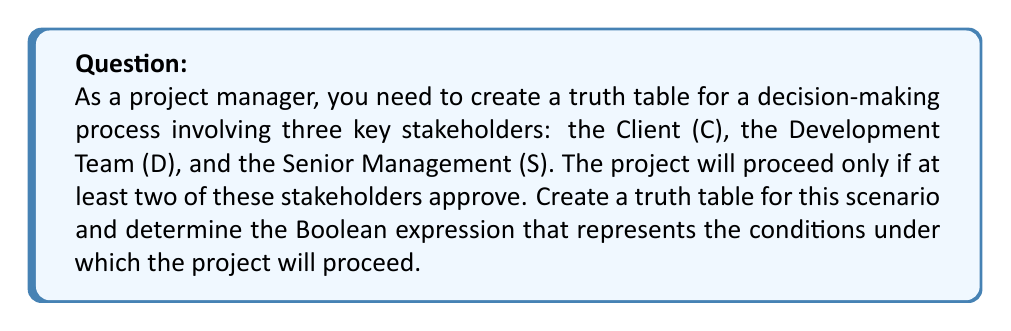What is the answer to this math problem? Let's approach this step-by-step:

1) First, we need to create a truth table with all possible combinations of approvals from the three stakeholders. Each stakeholder can either approve (1) or not approve (0).

2) The truth table will have $2^3 = 8$ rows, as there are three variables (C, D, S) with two possible states each.

3) Let's create the truth table:

   $$
   \begin{array}{|c|c|c|c|}
   \hline
   C & D & S & \text{Proceed?} \\
   \hline
   0 & 0 & 0 & 0 \\
   0 & 0 & 1 & 0 \\
   0 & 1 & 0 & 0 \\
   0 & 1 & 1 & 1 \\
   1 & 0 & 0 & 0 \\
   1 & 0 & 1 & 1 \\
   1 & 1 & 0 & 1 \\
   1 & 1 & 1 & 1 \\
   \hline
   \end{array}
   $$

4) The "Proceed?" column is 1 when at least two stakeholders approve.

5) To derive the Boolean expression, we can use the sum-of-products method. We'll write an OR ('+') of all the input combinations that result in a "Proceed" of 1:

   $$(C \cdot D \cdot \overline{S}) + (C \cdot \overline{D} \cdot S) + (\overline{C} \cdot D \cdot S) + (C \cdot D \cdot S)$$

6) This expression can be simplified using Boolean algebra. One way to simplify it is to recognize that it represents all cases where at least two variables are 1. This can be written as:

   $$(C \cdot D) + (C \cdot S) + (D \cdot S)$$

This simplified expression means the project proceeds if Client and Development Team approve, OR Client and Senior Management approve, OR Development Team and Senior Management approve.
Answer: $(C \cdot D) + (C \cdot S) + (D \cdot S)$ 